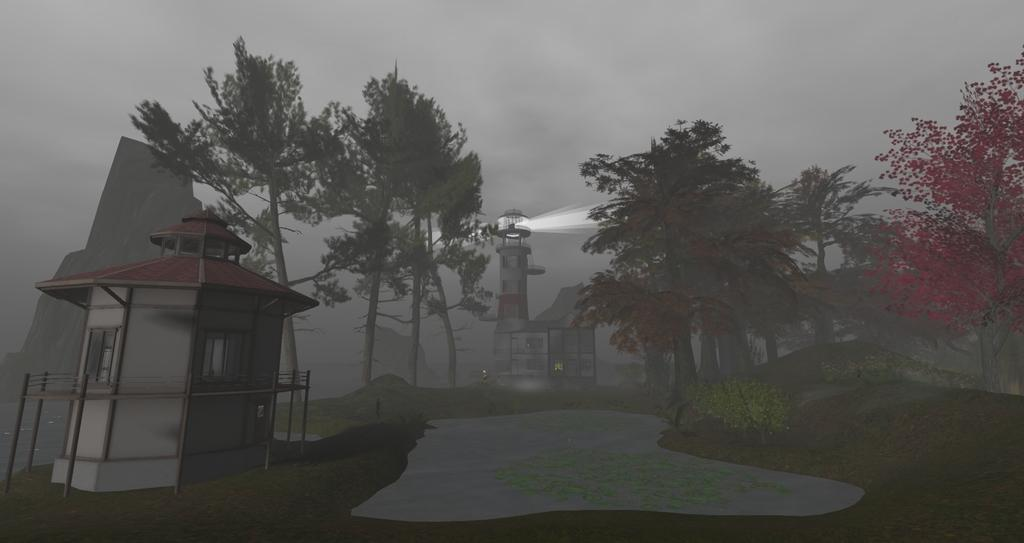What structures are visible in the image? There are towers in the image. What type of vegetation can be seen in the image? There are trees and plants in the image. What is the condition of the sky in the image? The sky is cloudy in the image. How many ladybugs are crawling on the towers in the image? There are no ladybugs present in the image; the focus is on the towers, trees, plants, and the cloudy sky. 